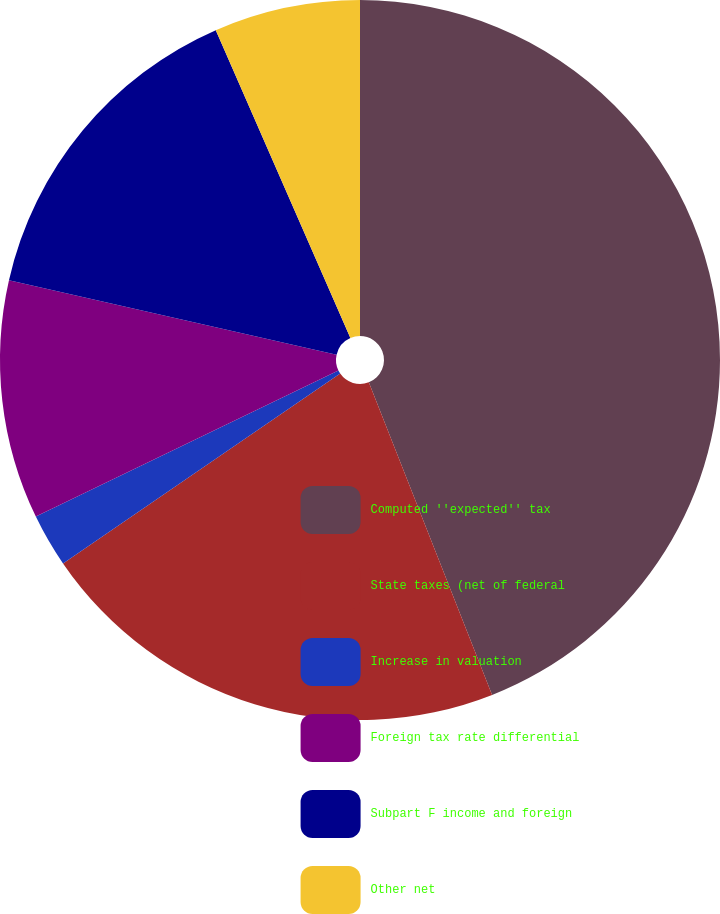Convert chart to OTSL. <chart><loc_0><loc_0><loc_500><loc_500><pie_chart><fcel>Computed ''expected'' tax<fcel>State taxes (net of federal<fcel>Increase in valuation<fcel>Foreign tax rate differential<fcel>Subpart F income and foreign<fcel>Other net<nl><fcel>44.02%<fcel>21.42%<fcel>2.4%<fcel>10.72%<fcel>14.88%<fcel>6.56%<nl></chart> 